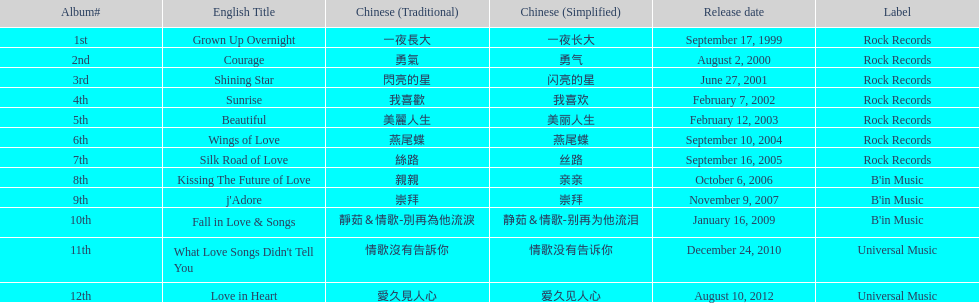Which album was launched later, beautiful or j'adore? J'adore. Could you parse the entire table? {'header': ['Album#', 'English Title', 'Chinese (Traditional)', 'Chinese (Simplified)', 'Release date', 'Label'], 'rows': [['1st', 'Grown Up Overnight', '一夜長大', '一夜长大', 'September 17, 1999', 'Rock Records'], ['2nd', 'Courage', '勇氣', '勇气', 'August 2, 2000', 'Rock Records'], ['3rd', 'Shining Star', '閃亮的星', '闪亮的星', 'June 27, 2001', 'Rock Records'], ['4th', 'Sunrise', '我喜歡', '我喜欢', 'February 7, 2002', 'Rock Records'], ['5th', 'Beautiful', '美麗人生', '美丽人生', 'February 12, 2003', 'Rock Records'], ['6th', 'Wings of Love', '燕尾蝶', '燕尾蝶', 'September 10, 2004', 'Rock Records'], ['7th', 'Silk Road of Love', '絲路', '丝路', 'September 16, 2005', 'Rock Records'], ['8th', 'Kissing The Future of Love', '親親', '亲亲', 'October 6, 2006', "B'in Music"], ['9th', "j'Adore", '崇拜', '崇拜', 'November 9, 2007', "B'in Music"], ['10th', 'Fall in Love & Songs', '靜茹＆情歌-別再為他流淚', '静茹＆情歌-别再为他流泪', 'January 16, 2009', "B'in Music"], ['11th', "What Love Songs Didn't Tell You", '情歌沒有告訴你', '情歌没有告诉你', 'December 24, 2010', 'Universal Music'], ['12th', 'Love in Heart', '愛久見人心', '爱久见人心', 'August 10, 2012', 'Universal Music']]} 